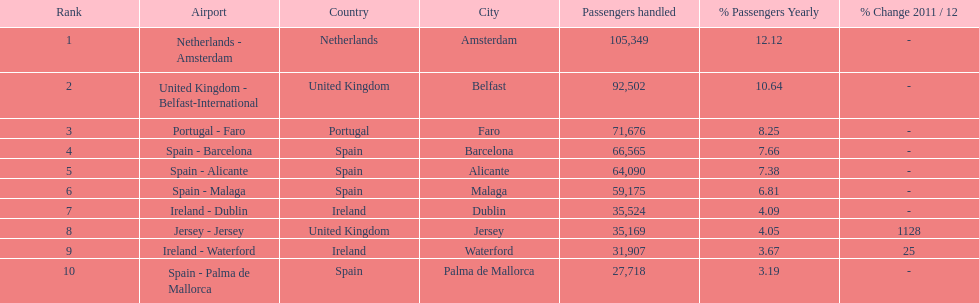Can you parse all the data within this table? {'header': ['Rank', 'Airport', 'Country', 'City', 'Passengers handled', '% Passengers Yearly', '% Change 2011 / 12'], 'rows': [['1', 'Netherlands - Amsterdam', 'Netherlands', 'Amsterdam', '105,349', '12.12', '-'], ['2', 'United Kingdom - Belfast-International', 'United Kingdom', 'Belfast', '92,502', '10.64', '-'], ['3', 'Portugal - Faro', 'Portugal', 'Faro', '71,676', '8.25', '-'], ['4', 'Spain - Barcelona', 'Spain', 'Barcelona', '66,565', '7.66', '-'], ['5', 'Spain - Alicante', 'Spain', 'Alicante', '64,090', '7.38', '-'], ['6', 'Spain - Malaga', 'Spain', 'Malaga', '59,175', '6.81', '-'], ['7', 'Ireland - Dublin', 'Ireland', 'Dublin', '35,524', '4.09', '-'], ['8', 'Jersey - Jersey', 'United Kingdom', 'Jersey', '35,169', '4.05', '1128'], ['9', 'Ireland - Waterford', 'Ireland', 'Waterford', '31,907', '3.67', '25'], ['10', 'Spain - Palma de Mallorca', 'Spain', 'Palma de Mallorca', '27,718', '3.19', '-']]} What is the name of the only airport in portugal that is among the 10 busiest routes to and from london southend airport in 2012? Portugal - Faro. 